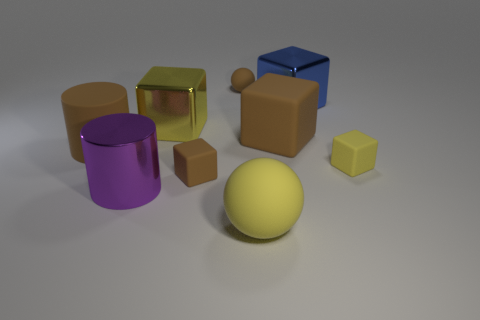Is there anything else that is made of the same material as the blue cube?
Your answer should be compact. Yes. What material is the yellow cube to the right of the shiny block that is left of the small brown object behind the big blue object?
Offer a very short reply. Rubber. There is a large block that is both on the right side of the big rubber ball and left of the blue object; what is its material?
Make the answer very short. Rubber. What number of brown things have the same shape as the large yellow shiny object?
Make the answer very short. 2. What size is the rubber sphere that is in front of the object right of the large blue object?
Provide a short and direct response. Large. Does the small thing that is left of the tiny matte ball have the same color as the sphere that is to the right of the tiny matte ball?
Offer a terse response. No. There is a large metallic thing that is right of the sphere in front of the blue cube; what number of blue cubes are right of it?
Your answer should be compact. 0. How many big yellow objects are both behind the purple shiny object and in front of the big purple metal cylinder?
Your answer should be compact. 0. Are there more blue metallic blocks behind the yellow metallic object than purple cylinders?
Offer a very short reply. No. How many other matte balls have the same size as the yellow rubber sphere?
Provide a succinct answer. 0. 